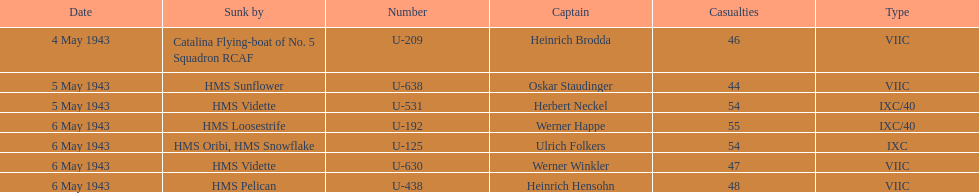Which ship sunk the most u-boats HMS Vidette. 